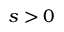<formula> <loc_0><loc_0><loc_500><loc_500>s > 0</formula> 